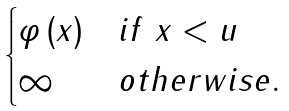Convert formula to latex. <formula><loc_0><loc_0><loc_500><loc_500>\begin{cases} \varphi \left ( x \right ) & i f \ x < u \\ \infty & o t h e r w i s e . \end{cases}</formula> 